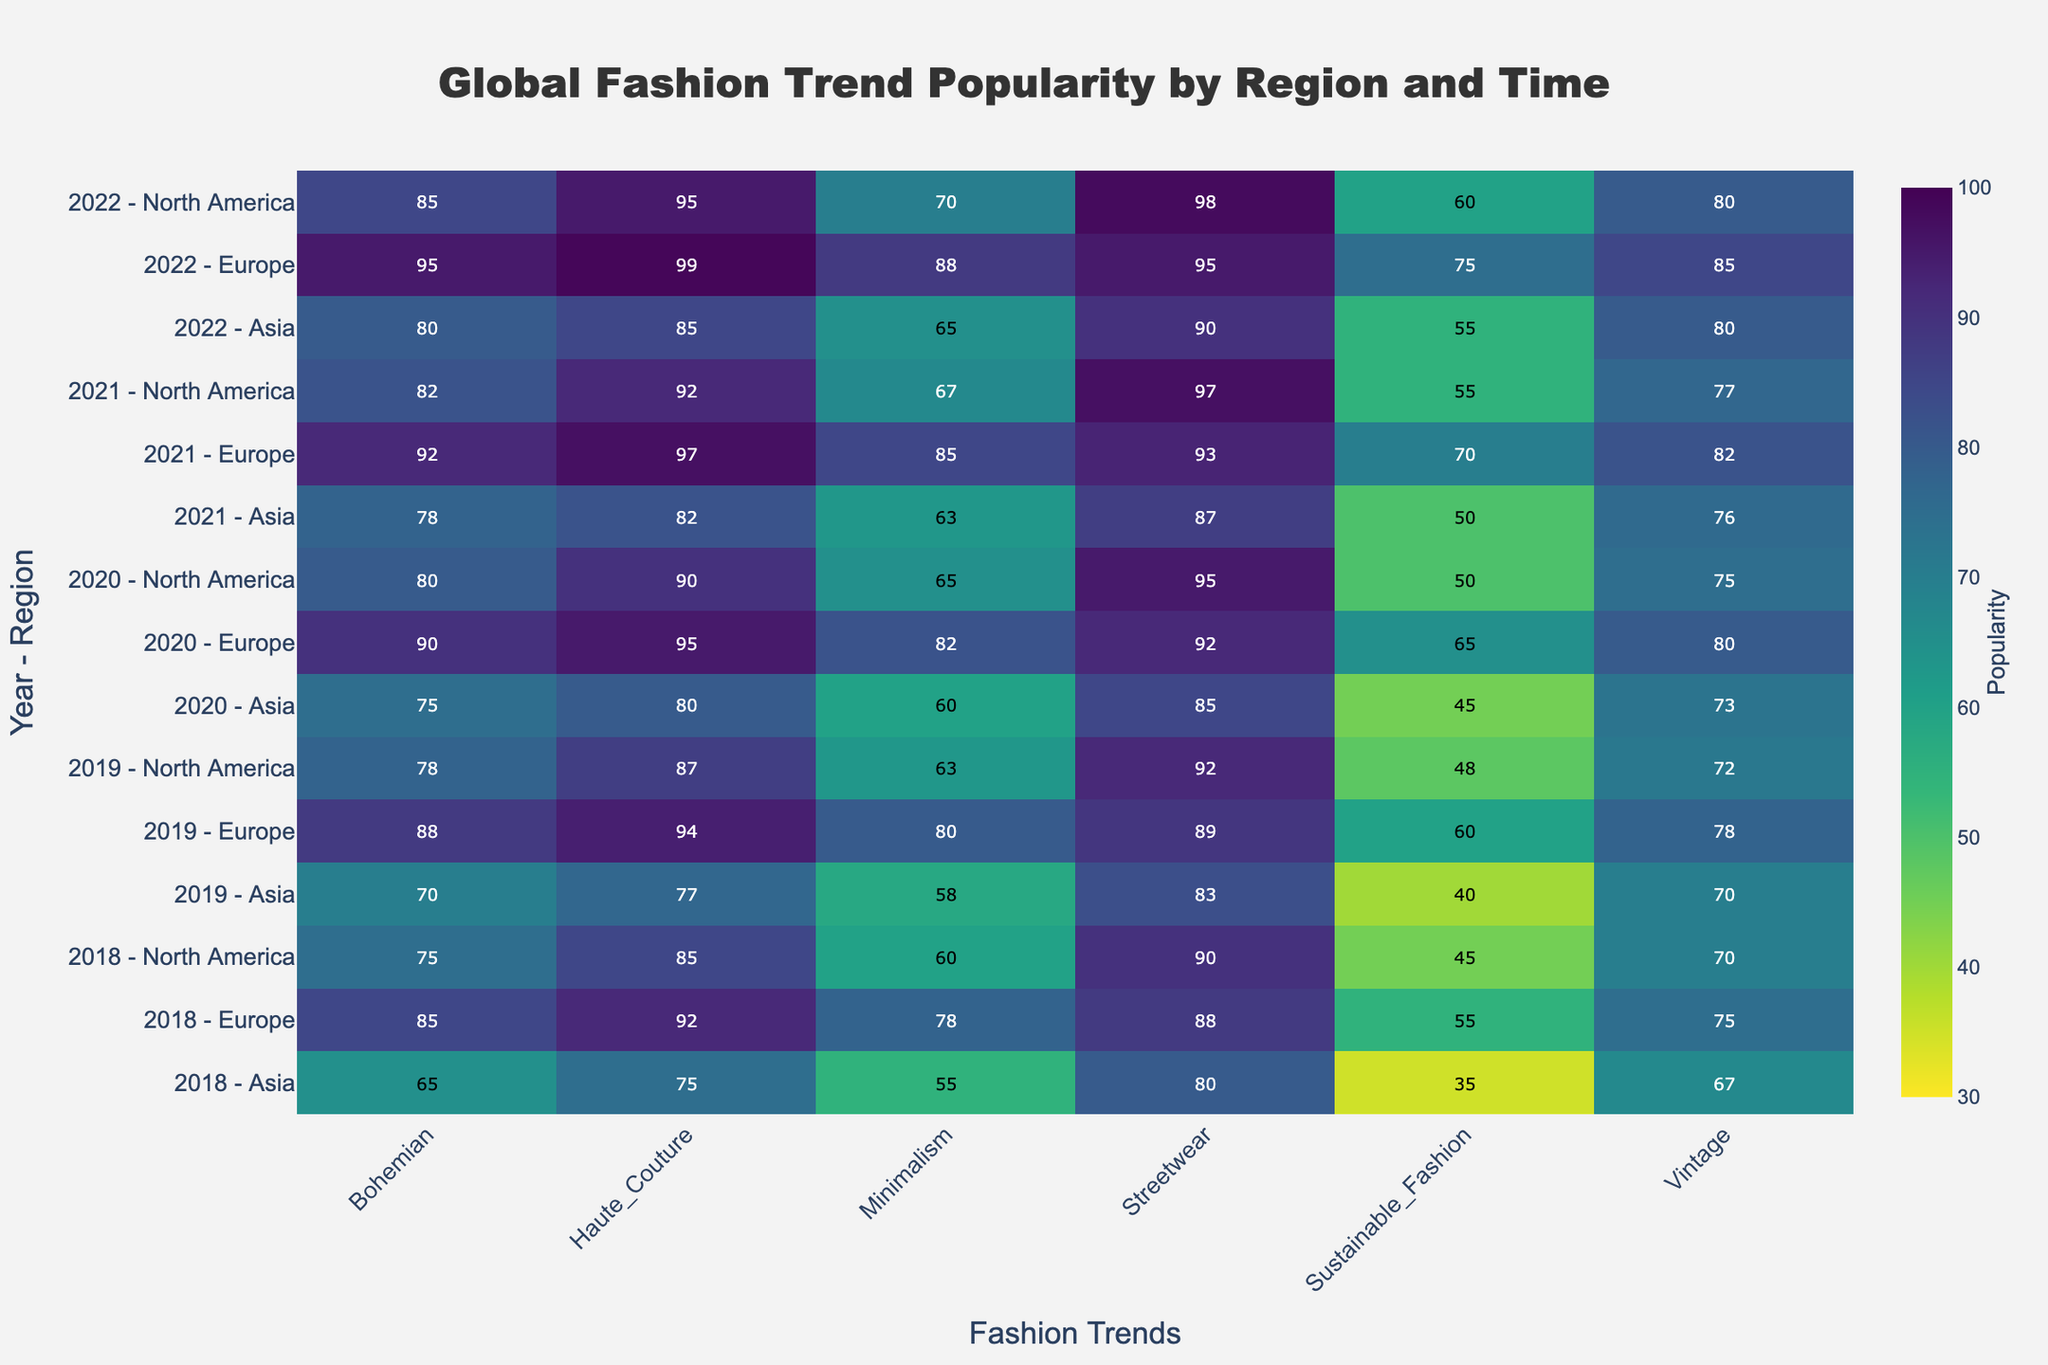What is the title of the heatmap? The title of the heatmap is displayed at the top of the figure. It reads "Global Fashion Trend Popularity by Region and Time".
Answer: Global Fashion Trend Popularity by Region and Time Which year and region combination has the highest popularity for the Streetwear trend? Look for the highest value in the Streetwear column and identify the corresponding year and region combination to the left.
Answer: 2022 - North America In which year did North America see the least popularity in the Sustainable Fashion trend? Look through the North America rows and find the minimum value in the Sustainable Fashion column, then identify the corresponding year.
Answer: 2018 What's the average popularity for the Bohemian trend in Europe between 2018 and 2022? Sum the popularity values for the Bohemian trend in Europe from 2018 to 2022 and divide by the number of years (5). Values are 85, 88, 90, 92, and 95. (85 + 88 + 90 + 92 + 95) / 5 = 90
Answer: 90 Which fashion trend trend has shown a consistent increase in popularity in Asia from 2018 to 2022? Examine the trends in the Asia rows and look for the one where the values consistently increase over the years. Sustainable Fashion values rise from 35 to 55 steadily.
Answer: Sustainable Fashion How many regions are analyzed in the heatmap for each year? The Y-axis labels combine years and regions, showing patterns like "2018 - North America". Count the unique regions for any year. There are always three regions (North America, Europe, Asia) for each year.
Answer: 3 What is the least popular fashion trend across all regions in 2020? Look at the values in the 2020 rows for all trends and find the minimum value. The least value in 2020 is 45 in Asia for Sustainable Fashion.
Answer: Sustainable Fashion Compare the popularity of Haute Couture in Europe between 2019 and 2022. How much did it change? Find the values for Haute Couture in Europe for 2019 and 2022, which are 94 and 99 respectively. Calculate the difference, 99 - 94.
Answer: 5 Identify the year and region that has the most consistent popularity across all fashion trends within that period. For each year and region combination, calculate the range (maximum minus minimum) of popularity values across all trends. The smallest range indicates the most consistent popularity. The smallest range is 15 for Europe in 2022 (95 to 80).
Answer: 2022 - Europe 